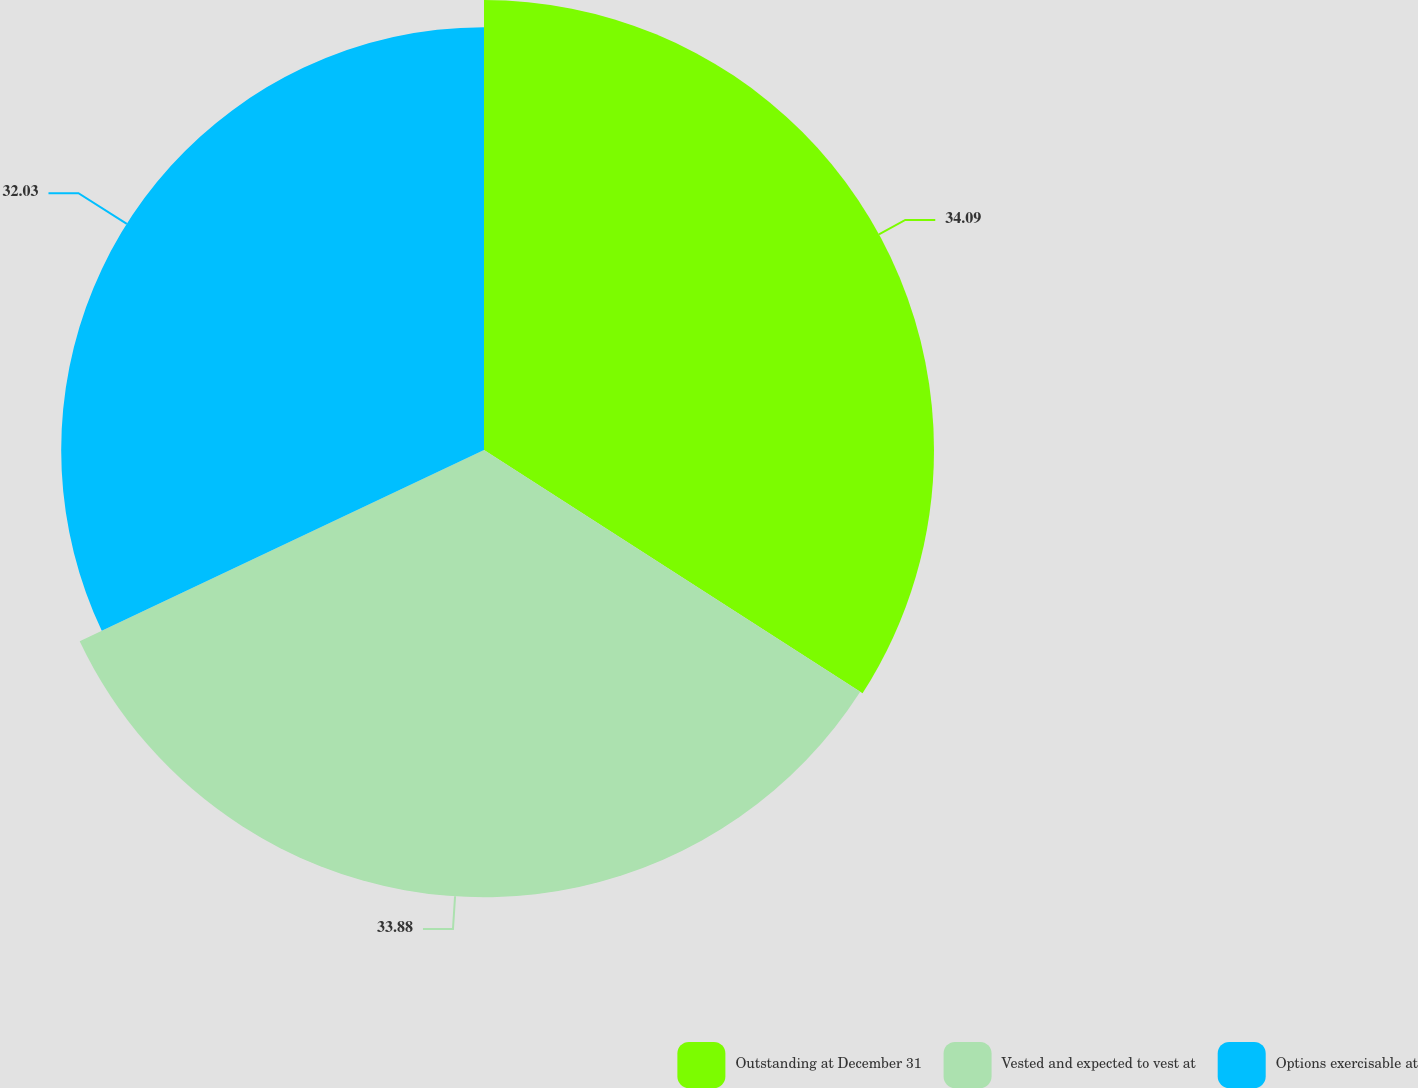Convert chart. <chart><loc_0><loc_0><loc_500><loc_500><pie_chart><fcel>Outstanding at December 31<fcel>Vested and expected to vest at<fcel>Options exercisable at<nl><fcel>34.09%<fcel>33.88%<fcel>32.03%<nl></chart> 